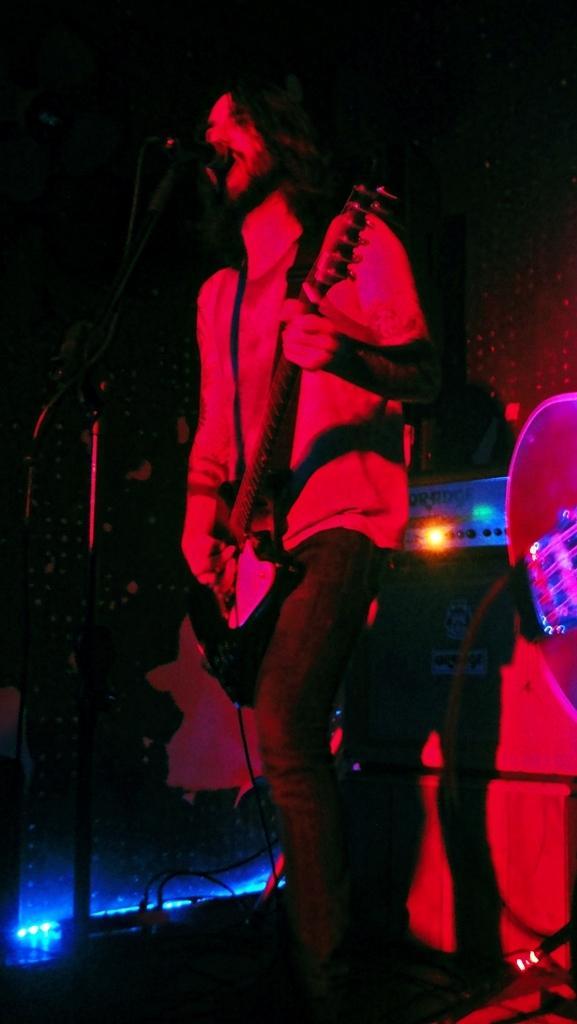Can you describe this image briefly? In this image there is one person who is standing and he is holding a guitar it seems that he is singing. In front of this man one mike is there and in the right side of the image there is one light. 